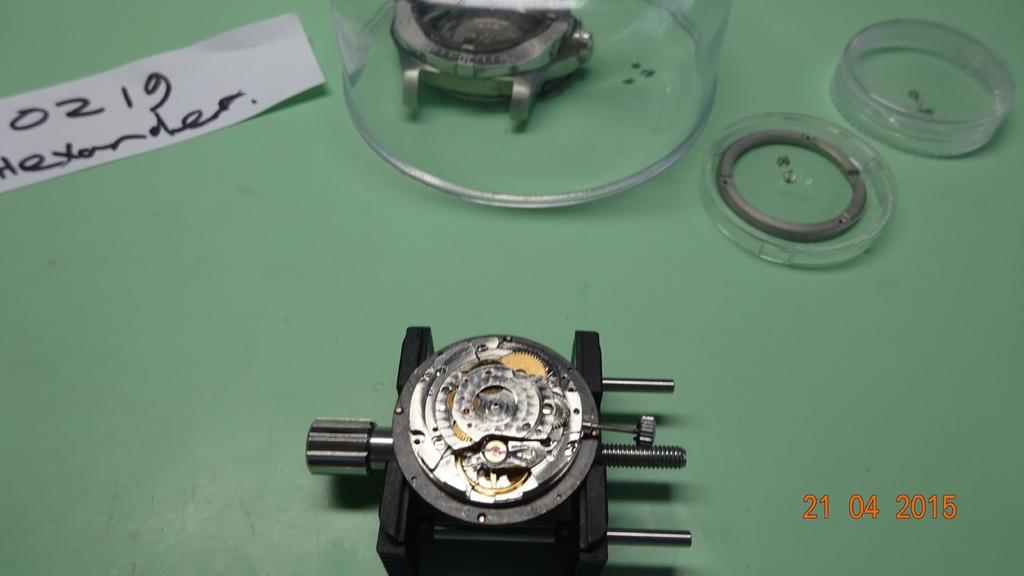<image>
Provide a brief description of the given image. A mechanical device on a green background in 2015 near a name tag for Alexander. 